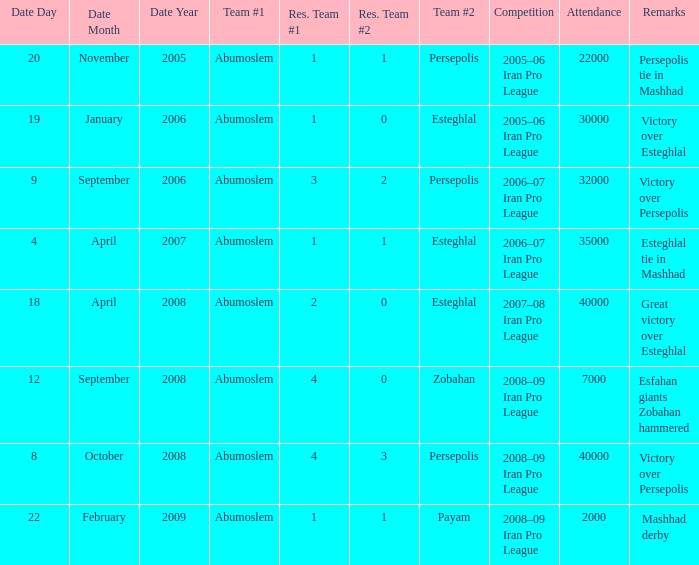What date was the attendance 22000? 20 November 2005. 